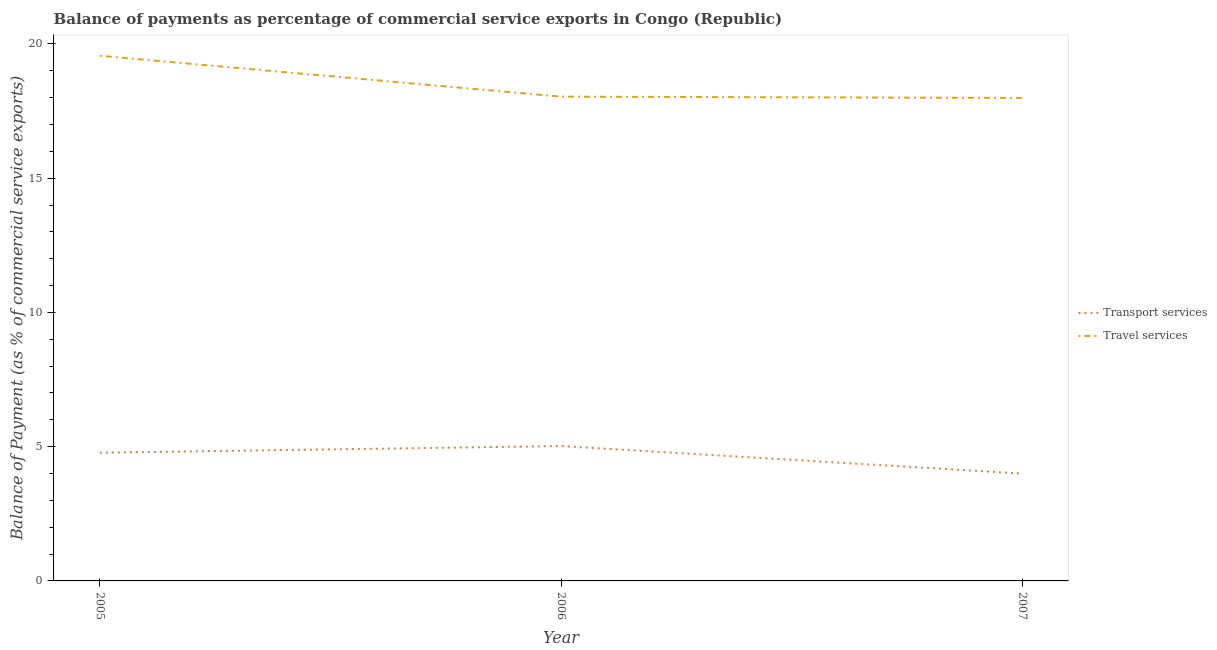How many different coloured lines are there?
Your response must be concise. 2. Does the line corresponding to balance of payments of transport services intersect with the line corresponding to balance of payments of travel services?
Make the answer very short. No. Is the number of lines equal to the number of legend labels?
Ensure brevity in your answer.  Yes. What is the balance of payments of travel services in 2006?
Your answer should be very brief. 18.04. Across all years, what is the maximum balance of payments of travel services?
Your answer should be compact. 19.56. Across all years, what is the minimum balance of payments of travel services?
Offer a very short reply. 17.99. In which year was the balance of payments of travel services maximum?
Your answer should be compact. 2005. What is the total balance of payments of transport services in the graph?
Offer a terse response. 13.8. What is the difference between the balance of payments of transport services in 2005 and that in 2007?
Keep it short and to the point. 0.78. What is the difference between the balance of payments of transport services in 2007 and the balance of payments of travel services in 2005?
Your answer should be very brief. -15.56. What is the average balance of payments of travel services per year?
Provide a short and direct response. 18.53. In the year 2006, what is the difference between the balance of payments of travel services and balance of payments of transport services?
Offer a terse response. 13.01. What is the ratio of the balance of payments of travel services in 2006 to that in 2007?
Your answer should be compact. 1. Is the balance of payments of transport services in 2006 less than that in 2007?
Your response must be concise. No. Is the difference between the balance of payments of travel services in 2005 and 2007 greater than the difference between the balance of payments of transport services in 2005 and 2007?
Keep it short and to the point. Yes. What is the difference between the highest and the second highest balance of payments of transport services?
Provide a succinct answer. 0.25. What is the difference between the highest and the lowest balance of payments of travel services?
Your answer should be compact. 1.57. In how many years, is the balance of payments of travel services greater than the average balance of payments of travel services taken over all years?
Offer a terse response. 1. Is the sum of the balance of payments of transport services in 2005 and 2006 greater than the maximum balance of payments of travel services across all years?
Make the answer very short. No. Is the balance of payments of travel services strictly greater than the balance of payments of transport services over the years?
Provide a succinct answer. Yes. How many years are there in the graph?
Make the answer very short. 3. What is the difference between two consecutive major ticks on the Y-axis?
Offer a terse response. 5. Does the graph contain grids?
Make the answer very short. No. How many legend labels are there?
Offer a terse response. 2. What is the title of the graph?
Your answer should be compact. Balance of payments as percentage of commercial service exports in Congo (Republic). Does "Formally registered" appear as one of the legend labels in the graph?
Offer a very short reply. No. What is the label or title of the Y-axis?
Ensure brevity in your answer.  Balance of Payment (as % of commercial service exports). What is the Balance of Payment (as % of commercial service exports) in Transport services in 2005?
Offer a terse response. 4.78. What is the Balance of Payment (as % of commercial service exports) in Travel services in 2005?
Provide a short and direct response. 19.56. What is the Balance of Payment (as % of commercial service exports) in Transport services in 2006?
Provide a short and direct response. 5.02. What is the Balance of Payment (as % of commercial service exports) of Travel services in 2006?
Provide a short and direct response. 18.04. What is the Balance of Payment (as % of commercial service exports) in Transport services in 2007?
Provide a succinct answer. 4. What is the Balance of Payment (as % of commercial service exports) of Travel services in 2007?
Offer a very short reply. 17.99. Across all years, what is the maximum Balance of Payment (as % of commercial service exports) of Transport services?
Your answer should be compact. 5.02. Across all years, what is the maximum Balance of Payment (as % of commercial service exports) in Travel services?
Keep it short and to the point. 19.56. Across all years, what is the minimum Balance of Payment (as % of commercial service exports) in Transport services?
Your response must be concise. 4. Across all years, what is the minimum Balance of Payment (as % of commercial service exports) of Travel services?
Provide a short and direct response. 17.99. What is the total Balance of Payment (as % of commercial service exports) of Transport services in the graph?
Give a very brief answer. 13.8. What is the total Balance of Payment (as % of commercial service exports) of Travel services in the graph?
Offer a terse response. 55.58. What is the difference between the Balance of Payment (as % of commercial service exports) in Transport services in 2005 and that in 2006?
Offer a terse response. -0.25. What is the difference between the Balance of Payment (as % of commercial service exports) of Travel services in 2005 and that in 2006?
Your response must be concise. 1.52. What is the difference between the Balance of Payment (as % of commercial service exports) in Travel services in 2005 and that in 2007?
Keep it short and to the point. 1.57. What is the difference between the Balance of Payment (as % of commercial service exports) in Transport services in 2006 and that in 2007?
Provide a succinct answer. 1.03. What is the difference between the Balance of Payment (as % of commercial service exports) in Travel services in 2006 and that in 2007?
Your response must be concise. 0.05. What is the difference between the Balance of Payment (as % of commercial service exports) of Transport services in 2005 and the Balance of Payment (as % of commercial service exports) of Travel services in 2006?
Your answer should be compact. -13.26. What is the difference between the Balance of Payment (as % of commercial service exports) of Transport services in 2005 and the Balance of Payment (as % of commercial service exports) of Travel services in 2007?
Your answer should be compact. -13.21. What is the difference between the Balance of Payment (as % of commercial service exports) of Transport services in 2006 and the Balance of Payment (as % of commercial service exports) of Travel services in 2007?
Your answer should be compact. -12.96. What is the average Balance of Payment (as % of commercial service exports) in Transport services per year?
Provide a succinct answer. 4.6. What is the average Balance of Payment (as % of commercial service exports) of Travel services per year?
Your answer should be compact. 18.53. In the year 2005, what is the difference between the Balance of Payment (as % of commercial service exports) of Transport services and Balance of Payment (as % of commercial service exports) of Travel services?
Make the answer very short. -14.78. In the year 2006, what is the difference between the Balance of Payment (as % of commercial service exports) in Transport services and Balance of Payment (as % of commercial service exports) in Travel services?
Your answer should be compact. -13.01. In the year 2007, what is the difference between the Balance of Payment (as % of commercial service exports) of Transport services and Balance of Payment (as % of commercial service exports) of Travel services?
Provide a short and direct response. -13.99. What is the ratio of the Balance of Payment (as % of commercial service exports) in Transport services in 2005 to that in 2006?
Offer a terse response. 0.95. What is the ratio of the Balance of Payment (as % of commercial service exports) of Travel services in 2005 to that in 2006?
Provide a succinct answer. 1.08. What is the ratio of the Balance of Payment (as % of commercial service exports) in Transport services in 2005 to that in 2007?
Make the answer very short. 1.19. What is the ratio of the Balance of Payment (as % of commercial service exports) of Travel services in 2005 to that in 2007?
Provide a succinct answer. 1.09. What is the ratio of the Balance of Payment (as % of commercial service exports) of Transport services in 2006 to that in 2007?
Provide a short and direct response. 1.26. What is the difference between the highest and the second highest Balance of Payment (as % of commercial service exports) in Transport services?
Provide a succinct answer. 0.25. What is the difference between the highest and the second highest Balance of Payment (as % of commercial service exports) of Travel services?
Your answer should be very brief. 1.52. What is the difference between the highest and the lowest Balance of Payment (as % of commercial service exports) in Transport services?
Provide a succinct answer. 1.03. What is the difference between the highest and the lowest Balance of Payment (as % of commercial service exports) in Travel services?
Your response must be concise. 1.57. 